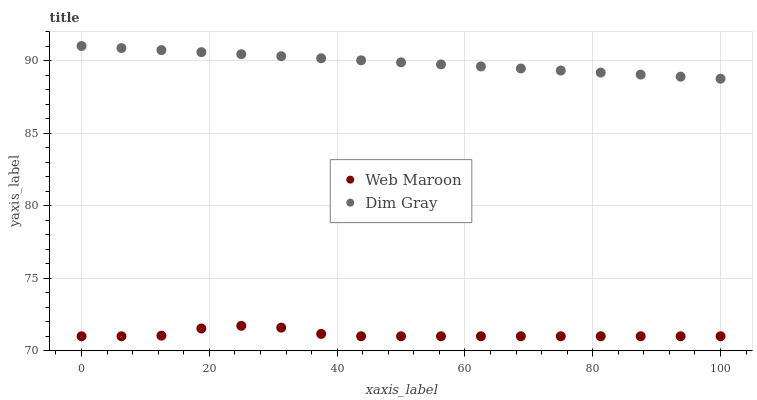Does Web Maroon have the minimum area under the curve?
Answer yes or no. Yes. Does Dim Gray have the maximum area under the curve?
Answer yes or no. Yes. Does Web Maroon have the maximum area under the curve?
Answer yes or no. No. Is Dim Gray the smoothest?
Answer yes or no. Yes. Is Web Maroon the roughest?
Answer yes or no. Yes. Is Web Maroon the smoothest?
Answer yes or no. No. Does Web Maroon have the lowest value?
Answer yes or no. Yes. Does Dim Gray have the highest value?
Answer yes or no. Yes. Does Web Maroon have the highest value?
Answer yes or no. No. Is Web Maroon less than Dim Gray?
Answer yes or no. Yes. Is Dim Gray greater than Web Maroon?
Answer yes or no. Yes. Does Web Maroon intersect Dim Gray?
Answer yes or no. No. 